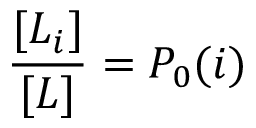Convert formula to latex. <formula><loc_0><loc_0><loc_500><loc_500>\frac { [ L _ { i } ] } { [ L ] } = P _ { 0 } ( i )</formula> 